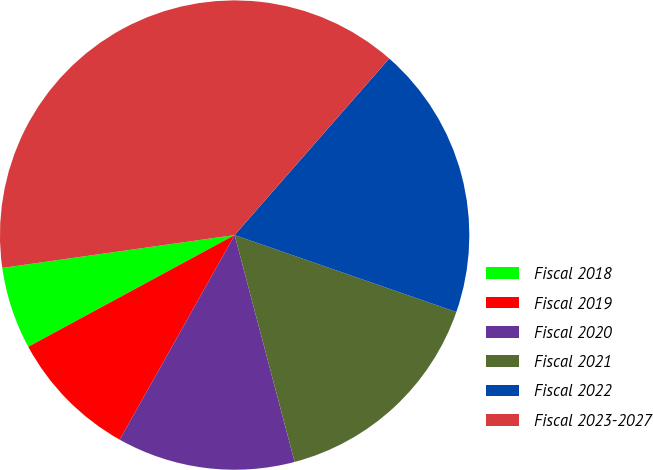<chart> <loc_0><loc_0><loc_500><loc_500><pie_chart><fcel>Fiscal 2018<fcel>Fiscal 2019<fcel>Fiscal 2020<fcel>Fiscal 2021<fcel>Fiscal 2022<fcel>Fiscal 2023-2027<nl><fcel>5.66%<fcel>8.96%<fcel>12.26%<fcel>15.57%<fcel>18.87%<fcel>38.68%<nl></chart> 